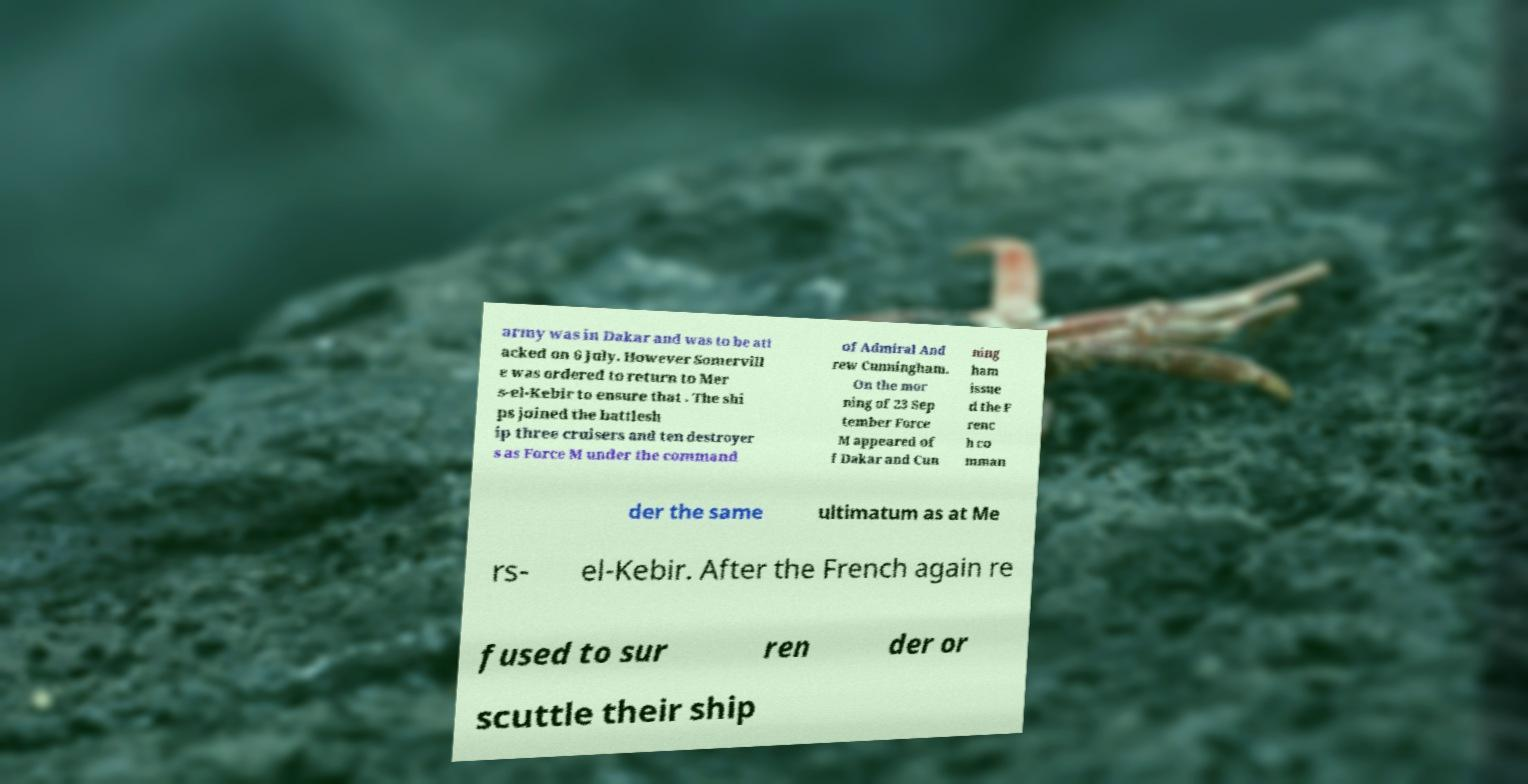What messages or text are displayed in this image? I need them in a readable, typed format. army was in Dakar and was to be att acked on 6 July. However Somervill e was ordered to return to Mer s-el-Kebir to ensure that . The shi ps joined the battlesh ip three cruisers and ten destroyer s as Force M under the command of Admiral And rew Cunningham. On the mor ning of 23 Sep tember Force M appeared of f Dakar and Cun ning ham issue d the F renc h co mman der the same ultimatum as at Me rs- el-Kebir. After the French again re fused to sur ren der or scuttle their ship 